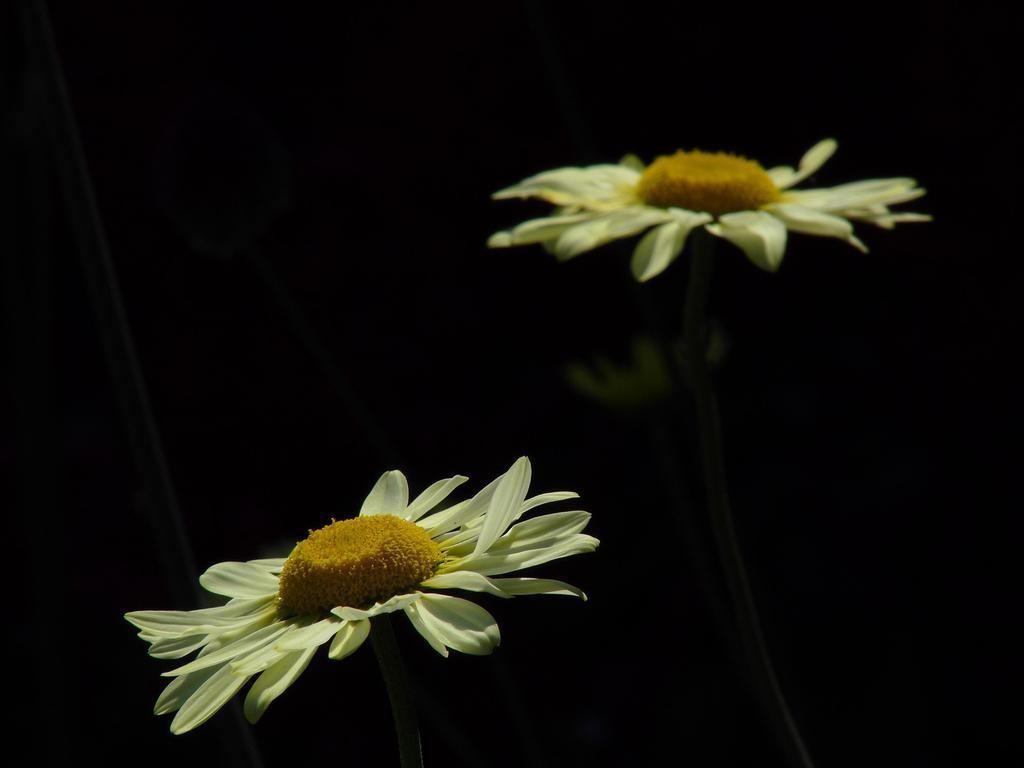What type of flowers are in the image? There are white sunflowers in the image. What type of mitten is being used to pick the white sunflowers in the image? There is no mitten present in the image, as it only features white sunflowers. 